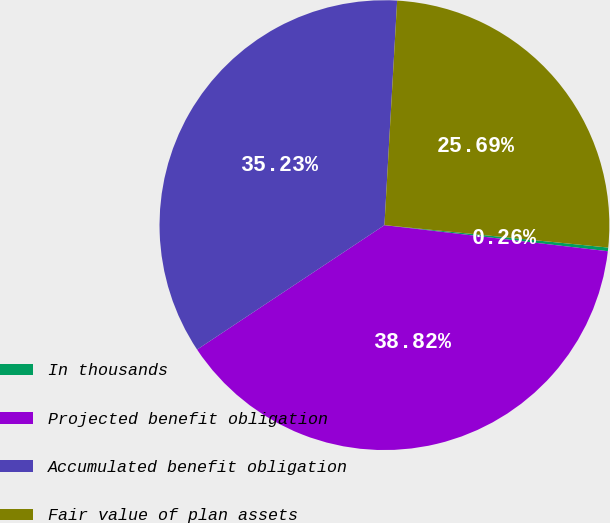Convert chart to OTSL. <chart><loc_0><loc_0><loc_500><loc_500><pie_chart><fcel>In thousands<fcel>Projected benefit obligation<fcel>Accumulated benefit obligation<fcel>Fair value of plan assets<nl><fcel>0.26%<fcel>38.82%<fcel>35.23%<fcel>25.69%<nl></chart> 